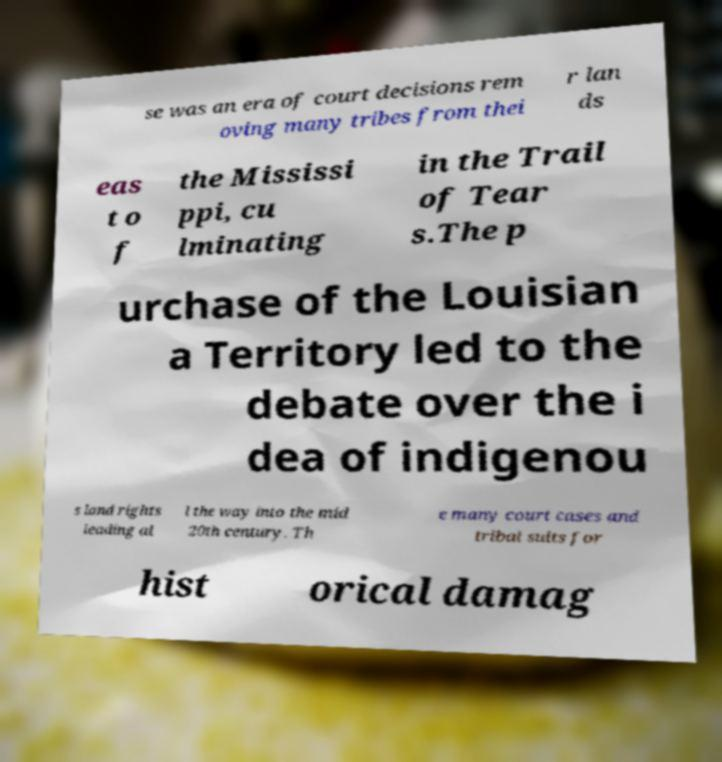There's text embedded in this image that I need extracted. Can you transcribe it verbatim? se was an era of court decisions rem oving many tribes from thei r lan ds eas t o f the Mississi ppi, cu lminating in the Trail of Tear s.The p urchase of the Louisian a Territory led to the debate over the i dea of indigenou s land rights leading al l the way into the mid 20th century. Th e many court cases and tribal suits for hist orical damag 